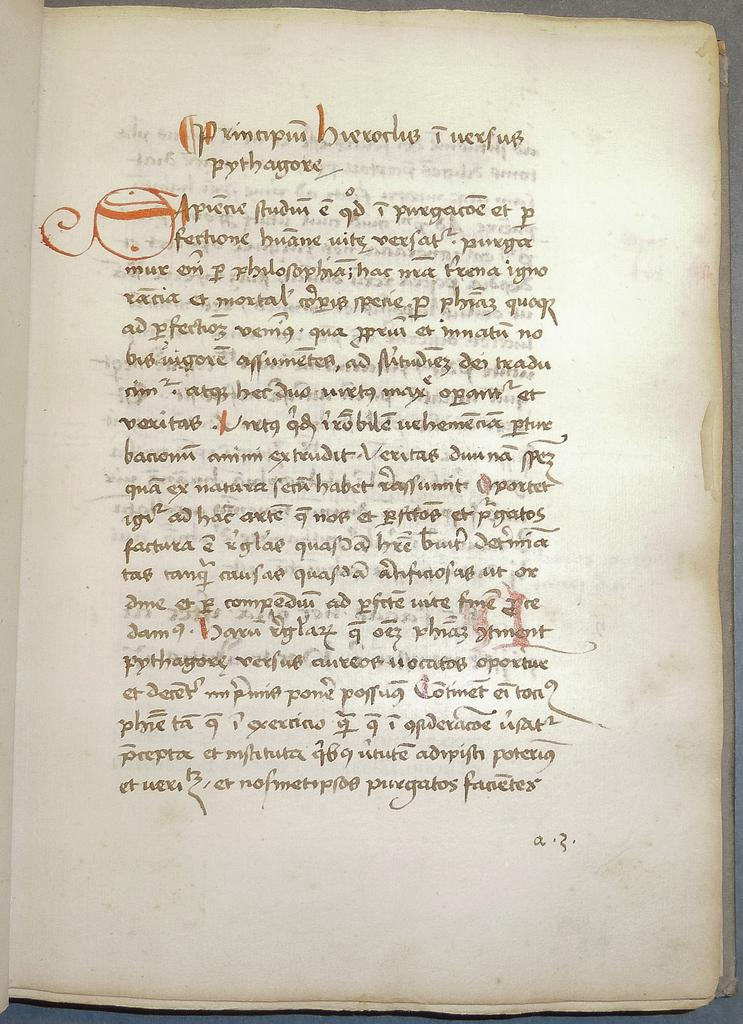<image>
Give a short and clear explanation of the subsequent image. An old hand written text in black ink dealing with Pythagore. 